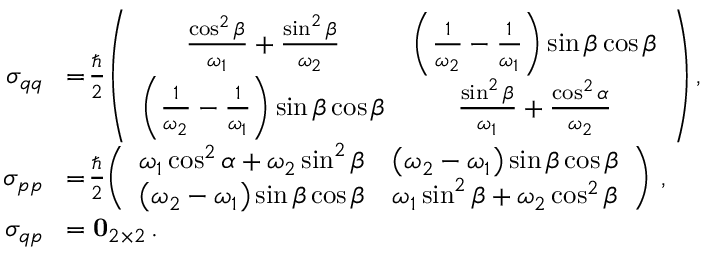<formula> <loc_0><loc_0><loc_500><loc_500>\begin{array} { r l } { \sigma _ { q q } } & { \, = \, \frac { } { 2 } \, \left ( \begin{array} { c c } { \frac { \cos ^ { 2 } \beta } { \omega _ { 1 } } + \frac { \sin ^ { 2 } \beta } { \omega _ { 2 } } } & { \left ( \frac { 1 } { \omega _ { 2 } } - \frac { 1 } { \omega _ { 1 } } \right ) \sin \beta \cos \beta } \\ { \left ( \frac { 1 } { \omega _ { 2 } } - \frac { 1 } { \omega _ { 1 } } \right ) \sin \beta \cos \beta } & { \frac { \sin ^ { 2 } \beta } { \omega _ { 1 } } + \frac { \cos ^ { 2 } \alpha } { \omega _ { 2 } } } \end{array} \right ) , } \\ { \sigma _ { p p } } & { \, = \, \frac { } { 2 } \, \left ( \begin{array} { c c } { \omega _ { 1 } \cos ^ { 2 } \alpha + \omega _ { 2 } \sin ^ { 2 } \beta } & { \left ( \omega _ { 2 } - \omega _ { 1 } \right ) \sin \beta \cos \beta } \\ { \left ( \omega _ { 2 } - \omega _ { 1 } \right ) \sin \beta \cos \beta } & { \omega _ { 1 } \sin ^ { 2 } \beta + \omega _ { 2 } \cos ^ { 2 } \beta } \end{array} \right ) \, , } \\ { \sigma _ { q p } } & { \, = 0 _ { 2 \times 2 } \, . } \end{array}</formula> 